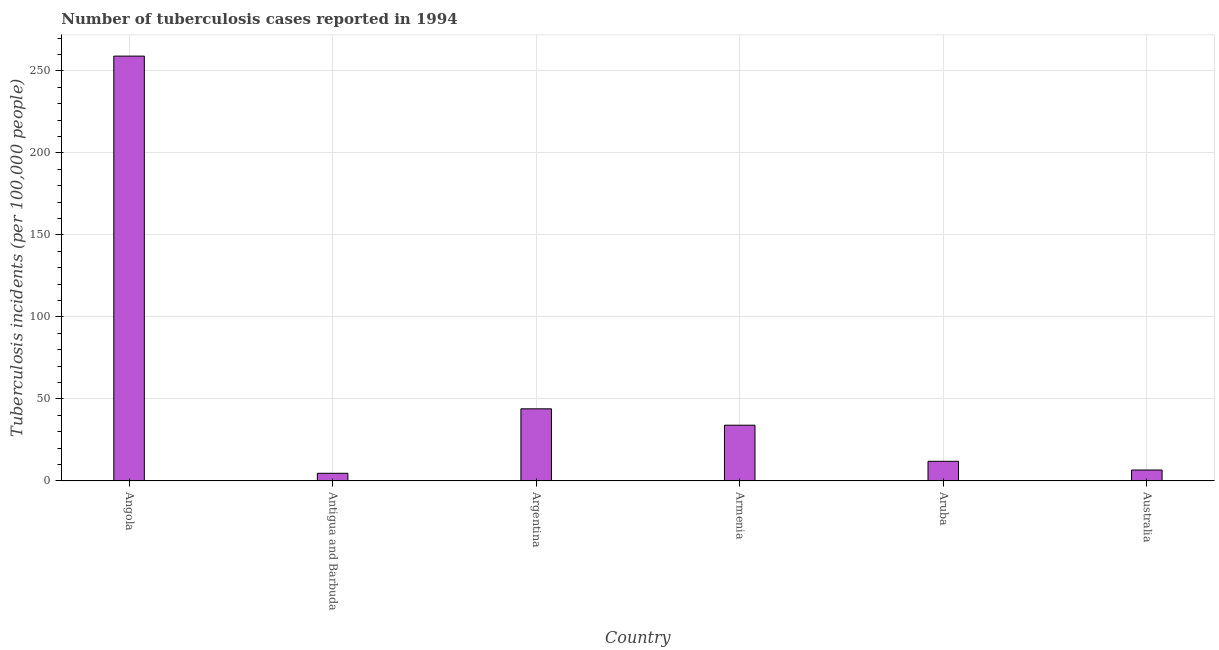Does the graph contain any zero values?
Your answer should be very brief. No. Does the graph contain grids?
Make the answer very short. Yes. What is the title of the graph?
Give a very brief answer. Number of tuberculosis cases reported in 1994. What is the label or title of the Y-axis?
Give a very brief answer. Tuberculosis incidents (per 100,0 people). What is the number of tuberculosis incidents in Antigua and Barbuda?
Ensure brevity in your answer.  4.7. Across all countries, what is the maximum number of tuberculosis incidents?
Your answer should be compact. 259. Across all countries, what is the minimum number of tuberculosis incidents?
Your answer should be compact. 4.7. In which country was the number of tuberculosis incidents maximum?
Your response must be concise. Angola. In which country was the number of tuberculosis incidents minimum?
Give a very brief answer. Antigua and Barbuda. What is the sum of the number of tuberculosis incidents?
Your response must be concise. 360.4. What is the difference between the number of tuberculosis incidents in Antigua and Barbuda and Australia?
Offer a very short reply. -2. What is the average number of tuberculosis incidents per country?
Keep it short and to the point. 60.07. What is the ratio of the number of tuberculosis incidents in Angola to that in Armenia?
Provide a short and direct response. 7.62. Is the difference between the number of tuberculosis incidents in Armenia and Aruba greater than the difference between any two countries?
Keep it short and to the point. No. What is the difference between the highest and the second highest number of tuberculosis incidents?
Your answer should be compact. 215. What is the difference between the highest and the lowest number of tuberculosis incidents?
Provide a short and direct response. 254.3. In how many countries, is the number of tuberculosis incidents greater than the average number of tuberculosis incidents taken over all countries?
Offer a terse response. 1. How many countries are there in the graph?
Your answer should be compact. 6. What is the difference between two consecutive major ticks on the Y-axis?
Offer a terse response. 50. What is the Tuberculosis incidents (per 100,000 people) in Angola?
Provide a succinct answer. 259. What is the Tuberculosis incidents (per 100,000 people) in Antigua and Barbuda?
Your answer should be very brief. 4.7. What is the Tuberculosis incidents (per 100,000 people) of Argentina?
Offer a very short reply. 44. What is the difference between the Tuberculosis incidents (per 100,000 people) in Angola and Antigua and Barbuda?
Keep it short and to the point. 254.3. What is the difference between the Tuberculosis incidents (per 100,000 people) in Angola and Argentina?
Provide a short and direct response. 215. What is the difference between the Tuberculosis incidents (per 100,000 people) in Angola and Armenia?
Your response must be concise. 225. What is the difference between the Tuberculosis incidents (per 100,000 people) in Angola and Aruba?
Your answer should be compact. 247. What is the difference between the Tuberculosis incidents (per 100,000 people) in Angola and Australia?
Your answer should be very brief. 252.3. What is the difference between the Tuberculosis incidents (per 100,000 people) in Antigua and Barbuda and Argentina?
Offer a very short reply. -39.3. What is the difference between the Tuberculosis incidents (per 100,000 people) in Antigua and Barbuda and Armenia?
Make the answer very short. -29.3. What is the difference between the Tuberculosis incidents (per 100,000 people) in Antigua and Barbuda and Australia?
Your response must be concise. -2. What is the difference between the Tuberculosis incidents (per 100,000 people) in Argentina and Aruba?
Your answer should be compact. 32. What is the difference between the Tuberculosis incidents (per 100,000 people) in Argentina and Australia?
Keep it short and to the point. 37.3. What is the difference between the Tuberculosis incidents (per 100,000 people) in Armenia and Australia?
Make the answer very short. 27.3. What is the difference between the Tuberculosis incidents (per 100,000 people) in Aruba and Australia?
Your response must be concise. 5.3. What is the ratio of the Tuberculosis incidents (per 100,000 people) in Angola to that in Antigua and Barbuda?
Your response must be concise. 55.11. What is the ratio of the Tuberculosis incidents (per 100,000 people) in Angola to that in Argentina?
Give a very brief answer. 5.89. What is the ratio of the Tuberculosis incidents (per 100,000 people) in Angola to that in Armenia?
Ensure brevity in your answer.  7.62. What is the ratio of the Tuberculosis incidents (per 100,000 people) in Angola to that in Aruba?
Your answer should be very brief. 21.58. What is the ratio of the Tuberculosis incidents (per 100,000 people) in Angola to that in Australia?
Keep it short and to the point. 38.66. What is the ratio of the Tuberculosis incidents (per 100,000 people) in Antigua and Barbuda to that in Argentina?
Make the answer very short. 0.11. What is the ratio of the Tuberculosis incidents (per 100,000 people) in Antigua and Barbuda to that in Armenia?
Provide a short and direct response. 0.14. What is the ratio of the Tuberculosis incidents (per 100,000 people) in Antigua and Barbuda to that in Aruba?
Offer a very short reply. 0.39. What is the ratio of the Tuberculosis incidents (per 100,000 people) in Antigua and Barbuda to that in Australia?
Your answer should be compact. 0.7. What is the ratio of the Tuberculosis incidents (per 100,000 people) in Argentina to that in Armenia?
Provide a short and direct response. 1.29. What is the ratio of the Tuberculosis incidents (per 100,000 people) in Argentina to that in Aruba?
Your response must be concise. 3.67. What is the ratio of the Tuberculosis incidents (per 100,000 people) in Argentina to that in Australia?
Offer a terse response. 6.57. What is the ratio of the Tuberculosis incidents (per 100,000 people) in Armenia to that in Aruba?
Make the answer very short. 2.83. What is the ratio of the Tuberculosis incidents (per 100,000 people) in Armenia to that in Australia?
Make the answer very short. 5.08. What is the ratio of the Tuberculosis incidents (per 100,000 people) in Aruba to that in Australia?
Give a very brief answer. 1.79. 